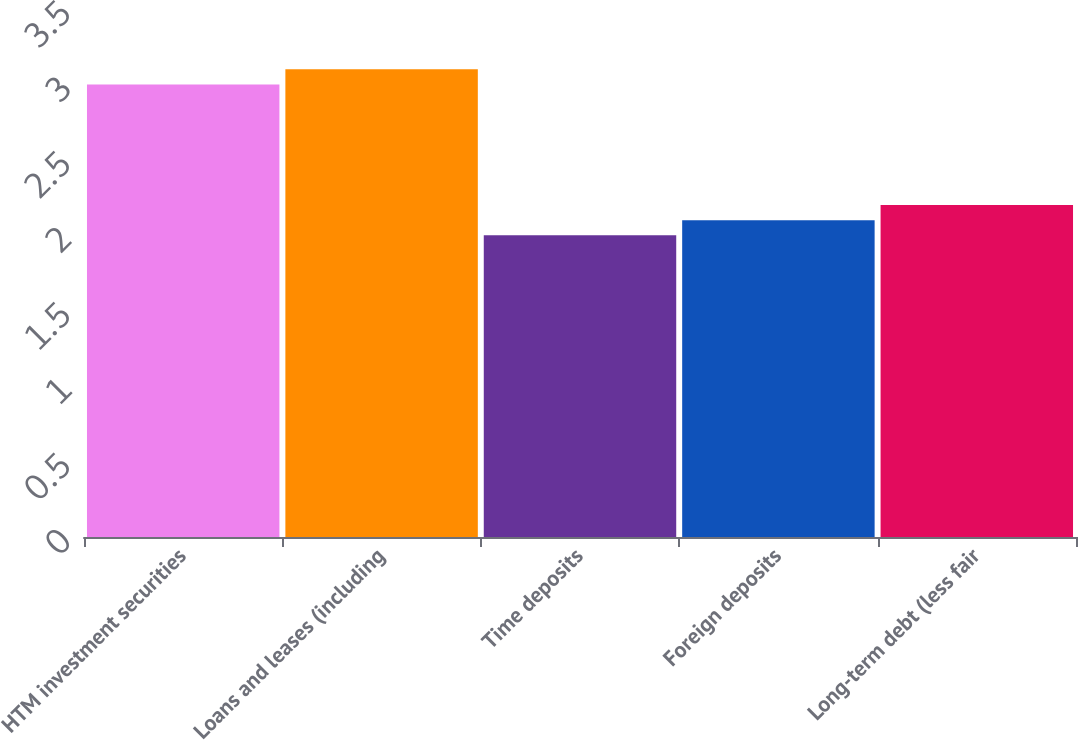Convert chart to OTSL. <chart><loc_0><loc_0><loc_500><loc_500><bar_chart><fcel>HTM investment securities<fcel>Loans and leases (including<fcel>Time deposits<fcel>Foreign deposits<fcel>Long-term debt (less fair<nl><fcel>3<fcel>3.1<fcel>2<fcel>2.1<fcel>2.2<nl></chart> 